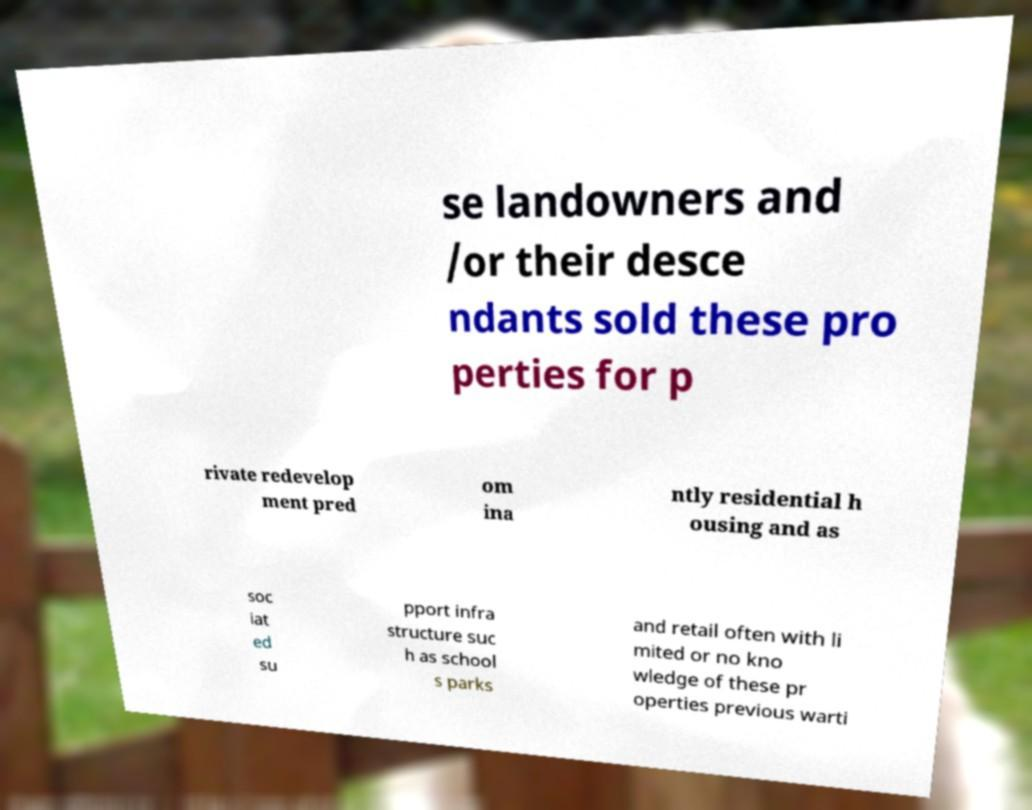I need the written content from this picture converted into text. Can you do that? se landowners and /or their desce ndants sold these pro perties for p rivate redevelop ment pred om ina ntly residential h ousing and as soc iat ed su pport infra structure suc h as school s parks and retail often with li mited or no kno wledge of these pr operties previous warti 